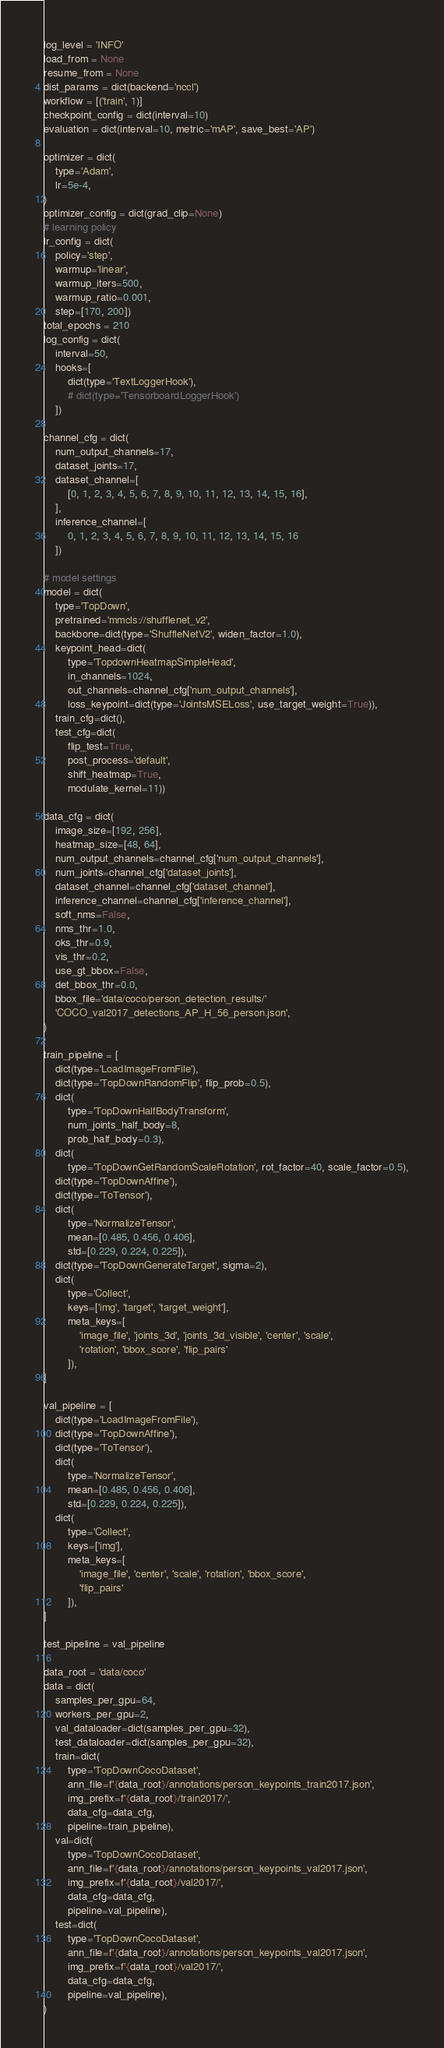Convert code to text. <code><loc_0><loc_0><loc_500><loc_500><_Python_>log_level = 'INFO'
load_from = None
resume_from = None
dist_params = dict(backend='nccl')
workflow = [('train', 1)]
checkpoint_config = dict(interval=10)
evaluation = dict(interval=10, metric='mAP', save_best='AP')

optimizer = dict(
    type='Adam',
    lr=5e-4,
)
optimizer_config = dict(grad_clip=None)
# learning policy
lr_config = dict(
    policy='step',
    warmup='linear',
    warmup_iters=500,
    warmup_ratio=0.001,
    step=[170, 200])
total_epochs = 210
log_config = dict(
    interval=50,
    hooks=[
        dict(type='TextLoggerHook'),
        # dict(type='TensorboardLoggerHook')
    ])

channel_cfg = dict(
    num_output_channels=17,
    dataset_joints=17,
    dataset_channel=[
        [0, 1, 2, 3, 4, 5, 6, 7, 8, 9, 10, 11, 12, 13, 14, 15, 16],
    ],
    inference_channel=[
        0, 1, 2, 3, 4, 5, 6, 7, 8, 9, 10, 11, 12, 13, 14, 15, 16
    ])

# model settings
model = dict(
    type='TopDown',
    pretrained='mmcls://shufflenet_v2',
    backbone=dict(type='ShuffleNetV2', widen_factor=1.0),
    keypoint_head=dict(
        type='TopdownHeatmapSimpleHead',
        in_channels=1024,
        out_channels=channel_cfg['num_output_channels'],
        loss_keypoint=dict(type='JointsMSELoss', use_target_weight=True)),
    train_cfg=dict(),
    test_cfg=dict(
        flip_test=True,
        post_process='default',
        shift_heatmap=True,
        modulate_kernel=11))

data_cfg = dict(
    image_size=[192, 256],
    heatmap_size=[48, 64],
    num_output_channels=channel_cfg['num_output_channels'],
    num_joints=channel_cfg['dataset_joints'],
    dataset_channel=channel_cfg['dataset_channel'],
    inference_channel=channel_cfg['inference_channel'],
    soft_nms=False,
    nms_thr=1.0,
    oks_thr=0.9,
    vis_thr=0.2,
    use_gt_bbox=False,
    det_bbox_thr=0.0,
    bbox_file='data/coco/person_detection_results/'
    'COCO_val2017_detections_AP_H_56_person.json',
)

train_pipeline = [
    dict(type='LoadImageFromFile'),
    dict(type='TopDownRandomFlip', flip_prob=0.5),
    dict(
        type='TopDownHalfBodyTransform',
        num_joints_half_body=8,
        prob_half_body=0.3),
    dict(
        type='TopDownGetRandomScaleRotation', rot_factor=40, scale_factor=0.5),
    dict(type='TopDownAffine'),
    dict(type='ToTensor'),
    dict(
        type='NormalizeTensor',
        mean=[0.485, 0.456, 0.406],
        std=[0.229, 0.224, 0.225]),
    dict(type='TopDownGenerateTarget', sigma=2),
    dict(
        type='Collect',
        keys=['img', 'target', 'target_weight'],
        meta_keys=[
            'image_file', 'joints_3d', 'joints_3d_visible', 'center', 'scale',
            'rotation', 'bbox_score', 'flip_pairs'
        ]),
]

val_pipeline = [
    dict(type='LoadImageFromFile'),
    dict(type='TopDownAffine'),
    dict(type='ToTensor'),
    dict(
        type='NormalizeTensor',
        mean=[0.485, 0.456, 0.406],
        std=[0.229, 0.224, 0.225]),
    dict(
        type='Collect',
        keys=['img'],
        meta_keys=[
            'image_file', 'center', 'scale', 'rotation', 'bbox_score',
            'flip_pairs'
        ]),
]

test_pipeline = val_pipeline

data_root = 'data/coco'
data = dict(
    samples_per_gpu=64,
    workers_per_gpu=2,
    val_dataloader=dict(samples_per_gpu=32),
    test_dataloader=dict(samples_per_gpu=32),
    train=dict(
        type='TopDownCocoDataset',
        ann_file=f'{data_root}/annotations/person_keypoints_train2017.json',
        img_prefix=f'{data_root}/train2017/',
        data_cfg=data_cfg,
        pipeline=train_pipeline),
    val=dict(
        type='TopDownCocoDataset',
        ann_file=f'{data_root}/annotations/person_keypoints_val2017.json',
        img_prefix=f'{data_root}/val2017/',
        data_cfg=data_cfg,
        pipeline=val_pipeline),
    test=dict(
        type='TopDownCocoDataset',
        ann_file=f'{data_root}/annotations/person_keypoints_val2017.json',
        img_prefix=f'{data_root}/val2017/',
        data_cfg=data_cfg,
        pipeline=val_pipeline),
)
</code> 